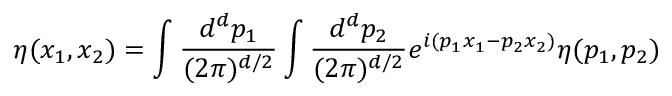Convert formula to latex. <formula><loc_0><loc_0><loc_500><loc_500>\eta ( x _ { 1 } , x _ { 2 } ) = \int { \frac { d ^ { d } p _ { 1 } } { ( 2 \pi ) ^ { d / 2 } } } \int { \frac { d ^ { d } p _ { 2 } } { ( 2 \pi ) ^ { d / 2 } } } e ^ { i ( p _ { 1 } x _ { 1 } - p _ { 2 } x _ { 2 } ) } \eta ( p _ { 1 } , p _ { 2 } )</formula> 